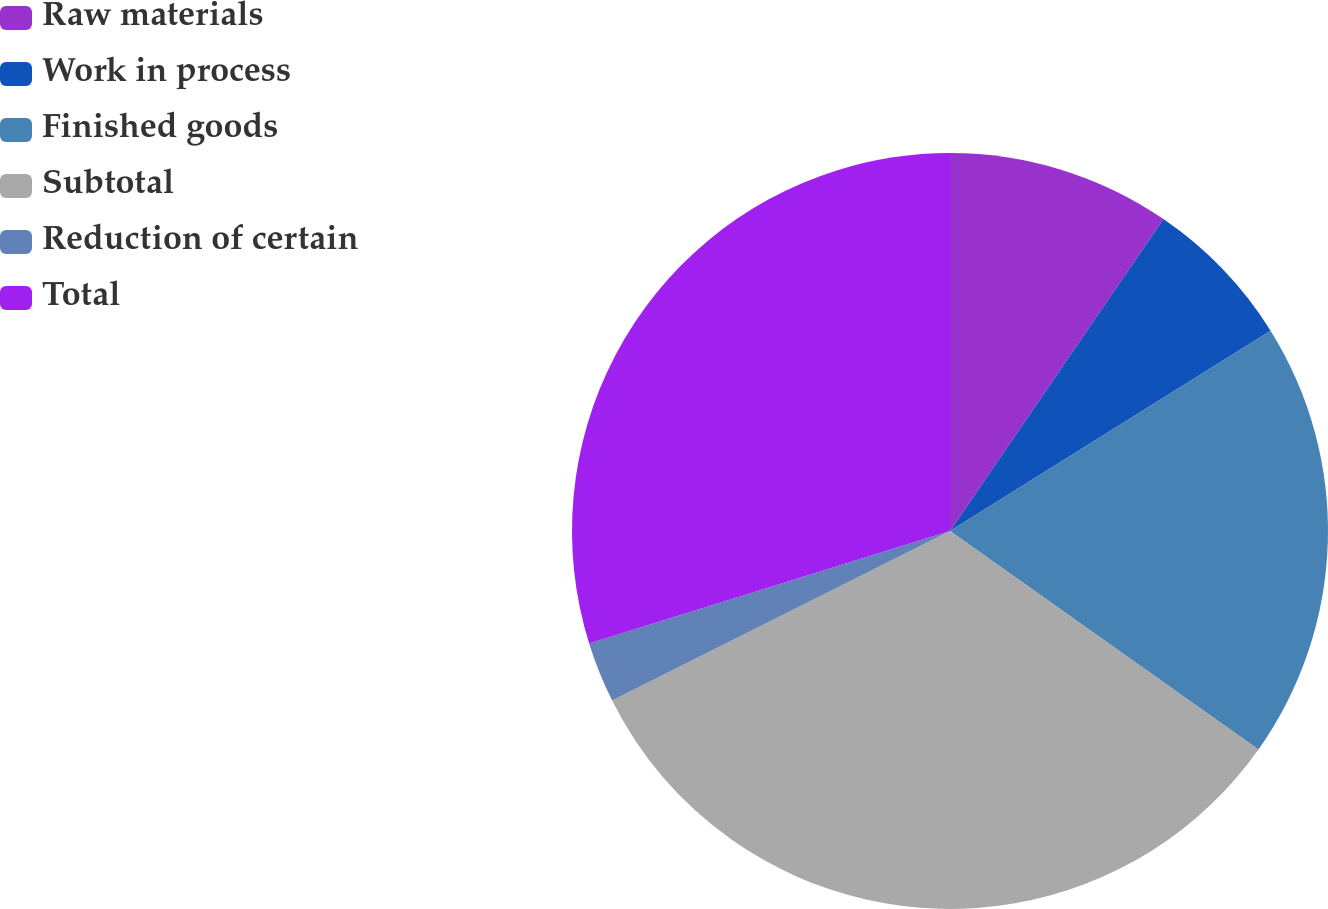Convert chart to OTSL. <chart><loc_0><loc_0><loc_500><loc_500><pie_chart><fcel>Raw materials<fcel>Work in process<fcel>Finished goods<fcel>Subtotal<fcel>Reduction of certain<fcel>Total<nl><fcel>9.55%<fcel>6.56%<fcel>18.7%<fcel>32.79%<fcel>2.59%<fcel>29.81%<nl></chart> 